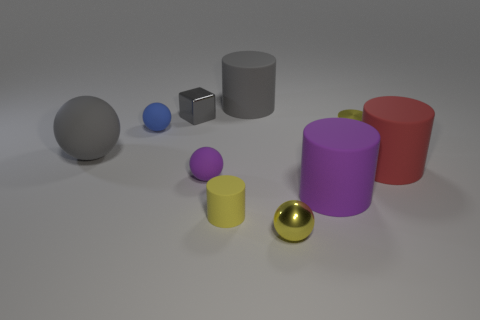Subtract 1 spheres. How many spheres are left? 3 Subtract all green cylinders. Subtract all green cubes. How many cylinders are left? 5 Subtract all blocks. How many objects are left? 9 Subtract 2 yellow cylinders. How many objects are left? 8 Subtract all tiny yellow metallic objects. Subtract all purple cylinders. How many objects are left? 7 Add 7 gray objects. How many gray objects are left? 10 Add 2 tiny blue spheres. How many tiny blue spheres exist? 3 